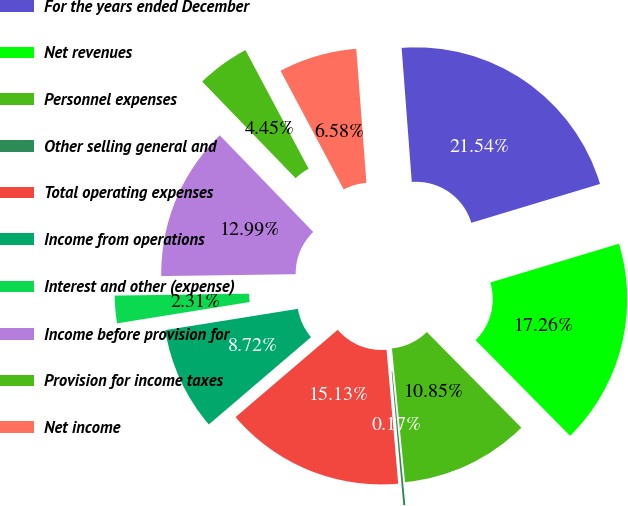Convert chart. <chart><loc_0><loc_0><loc_500><loc_500><pie_chart><fcel>For the years ended December<fcel>Net revenues<fcel>Personnel expenses<fcel>Other selling general and<fcel>Total operating expenses<fcel>Income from operations<fcel>Interest and other (expense)<fcel>Income before provision for<fcel>Provision for income taxes<fcel>Net income<nl><fcel>21.54%<fcel>17.26%<fcel>10.85%<fcel>0.17%<fcel>15.13%<fcel>8.72%<fcel>2.31%<fcel>12.99%<fcel>4.45%<fcel>6.58%<nl></chart> 